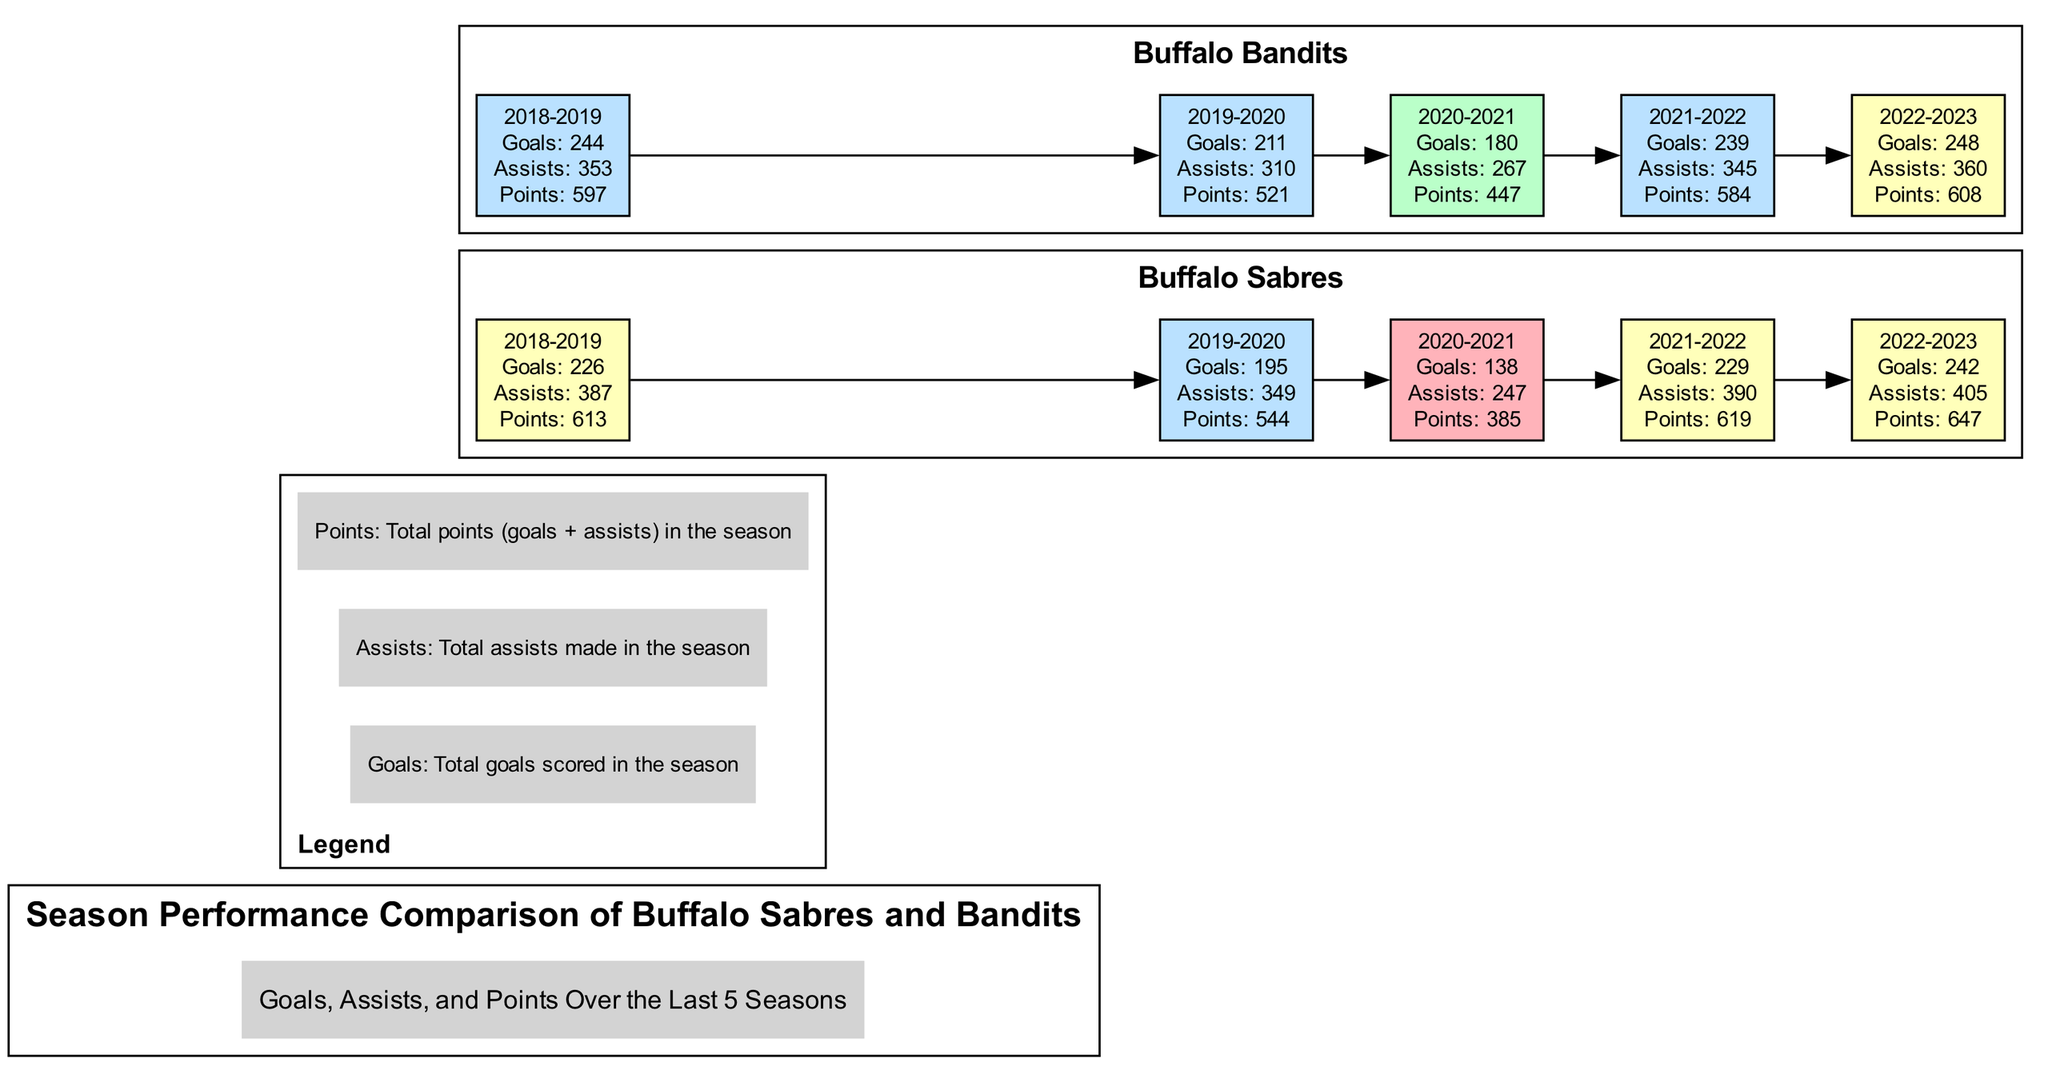What was the goal total for the Buffalo Sabres in the 2021-2022 season? The diagram indicates that the Buffalo Sabres scored 229 goals in the 2021-2022 season, which is directly stated in the node corresponding to that year.
Answer: 229 How many assists did the Buffalo Bandits have in the 2022-2023 season? The node for the Buffalo Bandits in the 2022-2023 season shows a total of 360 assists, which can be found in the relevant season section of the diagram.
Answer: 360 In which season did the Buffalo Sabres achieve the highest points total? By comparing the points across the seasons for the Buffalo Sabres, the highest total is 647 in the 2022-2023 season, visible on the corresponding node for that year.
Answer: 2022-2023 What are the total points scored by the Buffalo Bandits in 2019-2020? The node for the Buffalo Bandits in the 2019-2020 season indicates that they scored a total of 521 points, as displayed on that specific node.
Answer: 521 Which team had more goals in the 2018-2019 season? The diagram shows that the Buffalo Bandits scored 244 goals while the Buffalo Sabres scored 226 goals in the 2018-2019 season. Thus, the Bandits had more goals that season.
Answer: Bandits Compare the assists in the 2020-2021 season for both teams. The Buffalo Sabres had 247 assists while the Buffalo Bandits had 267 assists in the 2020-2021 season. Therefore, the Bandits had more assists by 20.
Answer: Bandits What color is used to represent the points total less than 400? Referring to the color codes in the diagram, points below 400 are represented with a light red color. This can be deduced from the color mapping provided in the diagram logic.
Answer: Light red How many edge connections are there for the Buffalo Sabres between the seasons? There are 4 edges connecting the Buffalo Sabres' seasons, indicating transitions from 2018-2019 to 2019-2020, 2019-2020 to 2020-2021, 2020-2021 to 2021-2022, and 2021-2022 to 2022-2023. Each edge represents a transition from one season to the next.
Answer: 4 Which year saw an increase in total points for the Buffalo Sabres compared to the previous year? The Buffalo Sabres saw an increase from 385 points in 2020-2021 to 619 points in 2021-2022, indicating a notable improvement. Therefore, the year 2021-2022 is the answer.
Answer: 2021-2022 